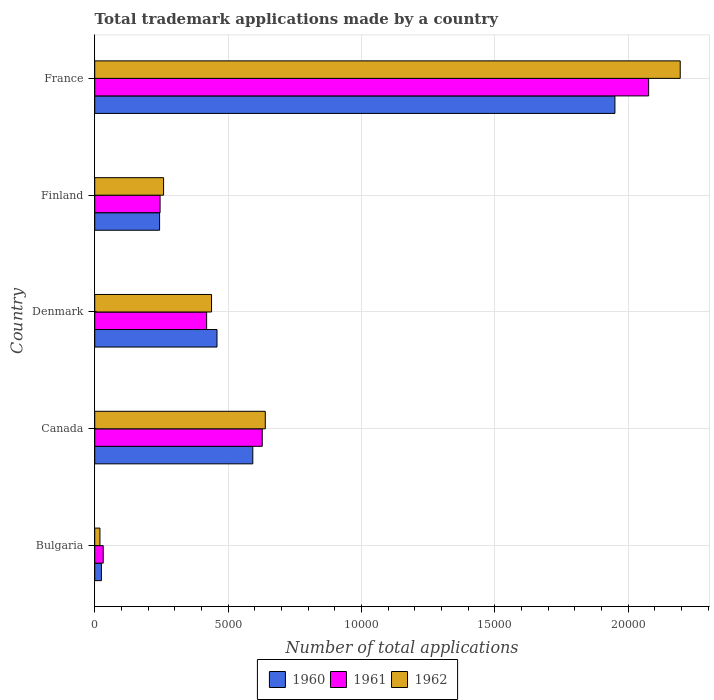How many different coloured bars are there?
Your response must be concise. 3. Are the number of bars per tick equal to the number of legend labels?
Offer a terse response. Yes. How many bars are there on the 3rd tick from the top?
Give a very brief answer. 3. How many bars are there on the 5th tick from the bottom?
Offer a very short reply. 3. What is the number of applications made by in 1960 in Bulgaria?
Ensure brevity in your answer.  250. Across all countries, what is the maximum number of applications made by in 1961?
Provide a short and direct response. 2.08e+04. Across all countries, what is the minimum number of applications made by in 1962?
Your response must be concise. 195. What is the total number of applications made by in 1962 in the graph?
Ensure brevity in your answer.  3.55e+04. What is the difference between the number of applications made by in 1960 in Canada and that in France?
Give a very brief answer. -1.36e+04. What is the difference between the number of applications made by in 1960 in Canada and the number of applications made by in 1962 in Finland?
Your response must be concise. 3345. What is the average number of applications made by in 1960 per country?
Your answer should be very brief. 6539.4. What is the difference between the number of applications made by in 1960 and number of applications made by in 1961 in Bulgaria?
Offer a very short reply. -68. In how many countries, is the number of applications made by in 1961 greater than 3000 ?
Offer a terse response. 3. What is the ratio of the number of applications made by in 1960 in Bulgaria to that in Denmark?
Make the answer very short. 0.05. Is the number of applications made by in 1960 in Canada less than that in Finland?
Keep it short and to the point. No. Is the difference between the number of applications made by in 1960 in Canada and Finland greater than the difference between the number of applications made by in 1961 in Canada and Finland?
Your response must be concise. No. What is the difference between the highest and the second highest number of applications made by in 1960?
Give a very brief answer. 1.36e+04. What is the difference between the highest and the lowest number of applications made by in 1961?
Ensure brevity in your answer.  2.04e+04. In how many countries, is the number of applications made by in 1961 greater than the average number of applications made by in 1961 taken over all countries?
Your answer should be compact. 1. Is the sum of the number of applications made by in 1960 in Denmark and France greater than the maximum number of applications made by in 1961 across all countries?
Offer a terse response. Yes. Is it the case that in every country, the sum of the number of applications made by in 1962 and number of applications made by in 1960 is greater than the number of applications made by in 1961?
Give a very brief answer. Yes. Are the values on the major ticks of X-axis written in scientific E-notation?
Make the answer very short. No. Does the graph contain any zero values?
Provide a succinct answer. No. Does the graph contain grids?
Make the answer very short. Yes. Where does the legend appear in the graph?
Provide a short and direct response. Bottom center. How are the legend labels stacked?
Your answer should be very brief. Horizontal. What is the title of the graph?
Give a very brief answer. Total trademark applications made by a country. What is the label or title of the X-axis?
Your answer should be compact. Number of total applications. What is the Number of total applications in 1960 in Bulgaria?
Ensure brevity in your answer.  250. What is the Number of total applications in 1961 in Bulgaria?
Keep it short and to the point. 318. What is the Number of total applications in 1962 in Bulgaria?
Provide a short and direct response. 195. What is the Number of total applications in 1960 in Canada?
Give a very brief answer. 5927. What is the Number of total applications in 1961 in Canada?
Offer a terse response. 6281. What is the Number of total applications in 1962 in Canada?
Make the answer very short. 6395. What is the Number of total applications of 1960 in Denmark?
Your answer should be very brief. 4584. What is the Number of total applications of 1961 in Denmark?
Offer a terse response. 4196. What is the Number of total applications in 1962 in Denmark?
Your answer should be compact. 4380. What is the Number of total applications in 1960 in Finland?
Ensure brevity in your answer.  2432. What is the Number of total applications of 1961 in Finland?
Keep it short and to the point. 2450. What is the Number of total applications of 1962 in Finland?
Provide a succinct answer. 2582. What is the Number of total applications in 1960 in France?
Your answer should be very brief. 1.95e+04. What is the Number of total applications of 1961 in France?
Your answer should be compact. 2.08e+04. What is the Number of total applications in 1962 in France?
Provide a short and direct response. 2.20e+04. Across all countries, what is the maximum Number of total applications of 1960?
Offer a very short reply. 1.95e+04. Across all countries, what is the maximum Number of total applications in 1961?
Provide a succinct answer. 2.08e+04. Across all countries, what is the maximum Number of total applications in 1962?
Offer a very short reply. 2.20e+04. Across all countries, what is the minimum Number of total applications in 1960?
Make the answer very short. 250. Across all countries, what is the minimum Number of total applications in 1961?
Ensure brevity in your answer.  318. Across all countries, what is the minimum Number of total applications in 1962?
Your answer should be compact. 195. What is the total Number of total applications of 1960 in the graph?
Ensure brevity in your answer.  3.27e+04. What is the total Number of total applications of 1961 in the graph?
Give a very brief answer. 3.40e+04. What is the total Number of total applications in 1962 in the graph?
Provide a succinct answer. 3.55e+04. What is the difference between the Number of total applications in 1960 in Bulgaria and that in Canada?
Offer a very short reply. -5677. What is the difference between the Number of total applications in 1961 in Bulgaria and that in Canada?
Provide a short and direct response. -5963. What is the difference between the Number of total applications of 1962 in Bulgaria and that in Canada?
Make the answer very short. -6200. What is the difference between the Number of total applications in 1960 in Bulgaria and that in Denmark?
Provide a short and direct response. -4334. What is the difference between the Number of total applications of 1961 in Bulgaria and that in Denmark?
Give a very brief answer. -3878. What is the difference between the Number of total applications in 1962 in Bulgaria and that in Denmark?
Offer a very short reply. -4185. What is the difference between the Number of total applications in 1960 in Bulgaria and that in Finland?
Your answer should be very brief. -2182. What is the difference between the Number of total applications in 1961 in Bulgaria and that in Finland?
Offer a terse response. -2132. What is the difference between the Number of total applications of 1962 in Bulgaria and that in Finland?
Your answer should be very brief. -2387. What is the difference between the Number of total applications in 1960 in Bulgaria and that in France?
Give a very brief answer. -1.93e+04. What is the difference between the Number of total applications of 1961 in Bulgaria and that in France?
Provide a short and direct response. -2.04e+04. What is the difference between the Number of total applications in 1962 in Bulgaria and that in France?
Your answer should be very brief. -2.18e+04. What is the difference between the Number of total applications in 1960 in Canada and that in Denmark?
Provide a short and direct response. 1343. What is the difference between the Number of total applications of 1961 in Canada and that in Denmark?
Offer a very short reply. 2085. What is the difference between the Number of total applications of 1962 in Canada and that in Denmark?
Give a very brief answer. 2015. What is the difference between the Number of total applications of 1960 in Canada and that in Finland?
Ensure brevity in your answer.  3495. What is the difference between the Number of total applications of 1961 in Canada and that in Finland?
Offer a very short reply. 3831. What is the difference between the Number of total applications in 1962 in Canada and that in Finland?
Offer a terse response. 3813. What is the difference between the Number of total applications of 1960 in Canada and that in France?
Offer a terse response. -1.36e+04. What is the difference between the Number of total applications of 1961 in Canada and that in France?
Offer a very short reply. -1.45e+04. What is the difference between the Number of total applications of 1962 in Canada and that in France?
Your answer should be compact. -1.56e+04. What is the difference between the Number of total applications of 1960 in Denmark and that in Finland?
Provide a succinct answer. 2152. What is the difference between the Number of total applications of 1961 in Denmark and that in Finland?
Make the answer very short. 1746. What is the difference between the Number of total applications in 1962 in Denmark and that in Finland?
Your answer should be compact. 1798. What is the difference between the Number of total applications of 1960 in Denmark and that in France?
Keep it short and to the point. -1.49e+04. What is the difference between the Number of total applications of 1961 in Denmark and that in France?
Offer a very short reply. -1.66e+04. What is the difference between the Number of total applications in 1962 in Denmark and that in France?
Your response must be concise. -1.76e+04. What is the difference between the Number of total applications of 1960 in Finland and that in France?
Keep it short and to the point. -1.71e+04. What is the difference between the Number of total applications of 1961 in Finland and that in France?
Ensure brevity in your answer.  -1.83e+04. What is the difference between the Number of total applications of 1962 in Finland and that in France?
Ensure brevity in your answer.  -1.94e+04. What is the difference between the Number of total applications of 1960 in Bulgaria and the Number of total applications of 1961 in Canada?
Your response must be concise. -6031. What is the difference between the Number of total applications of 1960 in Bulgaria and the Number of total applications of 1962 in Canada?
Provide a succinct answer. -6145. What is the difference between the Number of total applications in 1961 in Bulgaria and the Number of total applications in 1962 in Canada?
Offer a very short reply. -6077. What is the difference between the Number of total applications in 1960 in Bulgaria and the Number of total applications in 1961 in Denmark?
Your answer should be very brief. -3946. What is the difference between the Number of total applications of 1960 in Bulgaria and the Number of total applications of 1962 in Denmark?
Provide a short and direct response. -4130. What is the difference between the Number of total applications of 1961 in Bulgaria and the Number of total applications of 1962 in Denmark?
Make the answer very short. -4062. What is the difference between the Number of total applications of 1960 in Bulgaria and the Number of total applications of 1961 in Finland?
Provide a succinct answer. -2200. What is the difference between the Number of total applications in 1960 in Bulgaria and the Number of total applications in 1962 in Finland?
Provide a succinct answer. -2332. What is the difference between the Number of total applications of 1961 in Bulgaria and the Number of total applications of 1962 in Finland?
Keep it short and to the point. -2264. What is the difference between the Number of total applications of 1960 in Bulgaria and the Number of total applications of 1961 in France?
Your answer should be very brief. -2.05e+04. What is the difference between the Number of total applications of 1960 in Bulgaria and the Number of total applications of 1962 in France?
Give a very brief answer. -2.17e+04. What is the difference between the Number of total applications in 1961 in Bulgaria and the Number of total applications in 1962 in France?
Keep it short and to the point. -2.16e+04. What is the difference between the Number of total applications of 1960 in Canada and the Number of total applications of 1961 in Denmark?
Your response must be concise. 1731. What is the difference between the Number of total applications of 1960 in Canada and the Number of total applications of 1962 in Denmark?
Make the answer very short. 1547. What is the difference between the Number of total applications of 1961 in Canada and the Number of total applications of 1962 in Denmark?
Offer a very short reply. 1901. What is the difference between the Number of total applications of 1960 in Canada and the Number of total applications of 1961 in Finland?
Make the answer very short. 3477. What is the difference between the Number of total applications of 1960 in Canada and the Number of total applications of 1962 in Finland?
Your answer should be compact. 3345. What is the difference between the Number of total applications of 1961 in Canada and the Number of total applications of 1962 in Finland?
Provide a short and direct response. 3699. What is the difference between the Number of total applications of 1960 in Canada and the Number of total applications of 1961 in France?
Offer a very short reply. -1.48e+04. What is the difference between the Number of total applications of 1960 in Canada and the Number of total applications of 1962 in France?
Your answer should be very brief. -1.60e+04. What is the difference between the Number of total applications in 1961 in Canada and the Number of total applications in 1962 in France?
Your response must be concise. -1.57e+04. What is the difference between the Number of total applications in 1960 in Denmark and the Number of total applications in 1961 in Finland?
Give a very brief answer. 2134. What is the difference between the Number of total applications of 1960 in Denmark and the Number of total applications of 1962 in Finland?
Your answer should be compact. 2002. What is the difference between the Number of total applications of 1961 in Denmark and the Number of total applications of 1962 in Finland?
Offer a terse response. 1614. What is the difference between the Number of total applications of 1960 in Denmark and the Number of total applications of 1961 in France?
Your answer should be compact. -1.62e+04. What is the difference between the Number of total applications of 1960 in Denmark and the Number of total applications of 1962 in France?
Your answer should be very brief. -1.74e+04. What is the difference between the Number of total applications of 1961 in Denmark and the Number of total applications of 1962 in France?
Provide a short and direct response. -1.78e+04. What is the difference between the Number of total applications of 1960 in Finland and the Number of total applications of 1961 in France?
Make the answer very short. -1.83e+04. What is the difference between the Number of total applications in 1960 in Finland and the Number of total applications in 1962 in France?
Your answer should be very brief. -1.95e+04. What is the difference between the Number of total applications in 1961 in Finland and the Number of total applications in 1962 in France?
Ensure brevity in your answer.  -1.95e+04. What is the average Number of total applications of 1960 per country?
Your response must be concise. 6539.4. What is the average Number of total applications in 1961 per country?
Your response must be concise. 6802.6. What is the average Number of total applications of 1962 per country?
Keep it short and to the point. 7100.8. What is the difference between the Number of total applications in 1960 and Number of total applications in 1961 in Bulgaria?
Provide a short and direct response. -68. What is the difference between the Number of total applications in 1960 and Number of total applications in 1962 in Bulgaria?
Ensure brevity in your answer.  55. What is the difference between the Number of total applications in 1961 and Number of total applications in 1962 in Bulgaria?
Offer a very short reply. 123. What is the difference between the Number of total applications in 1960 and Number of total applications in 1961 in Canada?
Make the answer very short. -354. What is the difference between the Number of total applications in 1960 and Number of total applications in 1962 in Canada?
Your answer should be compact. -468. What is the difference between the Number of total applications in 1961 and Number of total applications in 1962 in Canada?
Your response must be concise. -114. What is the difference between the Number of total applications in 1960 and Number of total applications in 1961 in Denmark?
Your answer should be compact. 388. What is the difference between the Number of total applications in 1960 and Number of total applications in 1962 in Denmark?
Your answer should be very brief. 204. What is the difference between the Number of total applications in 1961 and Number of total applications in 1962 in Denmark?
Make the answer very short. -184. What is the difference between the Number of total applications of 1960 and Number of total applications of 1961 in Finland?
Your answer should be very brief. -18. What is the difference between the Number of total applications in 1960 and Number of total applications in 1962 in Finland?
Make the answer very short. -150. What is the difference between the Number of total applications in 1961 and Number of total applications in 1962 in Finland?
Make the answer very short. -132. What is the difference between the Number of total applications in 1960 and Number of total applications in 1961 in France?
Your answer should be very brief. -1264. What is the difference between the Number of total applications of 1960 and Number of total applications of 1962 in France?
Provide a short and direct response. -2448. What is the difference between the Number of total applications in 1961 and Number of total applications in 1962 in France?
Your answer should be compact. -1184. What is the ratio of the Number of total applications of 1960 in Bulgaria to that in Canada?
Keep it short and to the point. 0.04. What is the ratio of the Number of total applications in 1961 in Bulgaria to that in Canada?
Provide a succinct answer. 0.05. What is the ratio of the Number of total applications in 1962 in Bulgaria to that in Canada?
Your answer should be very brief. 0.03. What is the ratio of the Number of total applications in 1960 in Bulgaria to that in Denmark?
Your response must be concise. 0.05. What is the ratio of the Number of total applications in 1961 in Bulgaria to that in Denmark?
Ensure brevity in your answer.  0.08. What is the ratio of the Number of total applications in 1962 in Bulgaria to that in Denmark?
Ensure brevity in your answer.  0.04. What is the ratio of the Number of total applications in 1960 in Bulgaria to that in Finland?
Keep it short and to the point. 0.1. What is the ratio of the Number of total applications in 1961 in Bulgaria to that in Finland?
Give a very brief answer. 0.13. What is the ratio of the Number of total applications in 1962 in Bulgaria to that in Finland?
Offer a very short reply. 0.08. What is the ratio of the Number of total applications of 1960 in Bulgaria to that in France?
Offer a very short reply. 0.01. What is the ratio of the Number of total applications in 1961 in Bulgaria to that in France?
Offer a very short reply. 0.02. What is the ratio of the Number of total applications of 1962 in Bulgaria to that in France?
Keep it short and to the point. 0.01. What is the ratio of the Number of total applications of 1960 in Canada to that in Denmark?
Make the answer very short. 1.29. What is the ratio of the Number of total applications of 1961 in Canada to that in Denmark?
Make the answer very short. 1.5. What is the ratio of the Number of total applications of 1962 in Canada to that in Denmark?
Your answer should be compact. 1.46. What is the ratio of the Number of total applications of 1960 in Canada to that in Finland?
Your response must be concise. 2.44. What is the ratio of the Number of total applications of 1961 in Canada to that in Finland?
Offer a terse response. 2.56. What is the ratio of the Number of total applications of 1962 in Canada to that in Finland?
Provide a succinct answer. 2.48. What is the ratio of the Number of total applications in 1960 in Canada to that in France?
Give a very brief answer. 0.3. What is the ratio of the Number of total applications in 1961 in Canada to that in France?
Your answer should be compact. 0.3. What is the ratio of the Number of total applications of 1962 in Canada to that in France?
Offer a terse response. 0.29. What is the ratio of the Number of total applications in 1960 in Denmark to that in Finland?
Your response must be concise. 1.88. What is the ratio of the Number of total applications in 1961 in Denmark to that in Finland?
Provide a short and direct response. 1.71. What is the ratio of the Number of total applications of 1962 in Denmark to that in Finland?
Provide a succinct answer. 1.7. What is the ratio of the Number of total applications in 1960 in Denmark to that in France?
Keep it short and to the point. 0.23. What is the ratio of the Number of total applications of 1961 in Denmark to that in France?
Keep it short and to the point. 0.2. What is the ratio of the Number of total applications in 1962 in Denmark to that in France?
Provide a succinct answer. 0.2. What is the ratio of the Number of total applications in 1960 in Finland to that in France?
Offer a very short reply. 0.12. What is the ratio of the Number of total applications of 1961 in Finland to that in France?
Provide a succinct answer. 0.12. What is the ratio of the Number of total applications of 1962 in Finland to that in France?
Your response must be concise. 0.12. What is the difference between the highest and the second highest Number of total applications in 1960?
Your answer should be compact. 1.36e+04. What is the difference between the highest and the second highest Number of total applications of 1961?
Your answer should be very brief. 1.45e+04. What is the difference between the highest and the second highest Number of total applications of 1962?
Your response must be concise. 1.56e+04. What is the difference between the highest and the lowest Number of total applications of 1960?
Offer a very short reply. 1.93e+04. What is the difference between the highest and the lowest Number of total applications in 1961?
Provide a short and direct response. 2.04e+04. What is the difference between the highest and the lowest Number of total applications in 1962?
Give a very brief answer. 2.18e+04. 